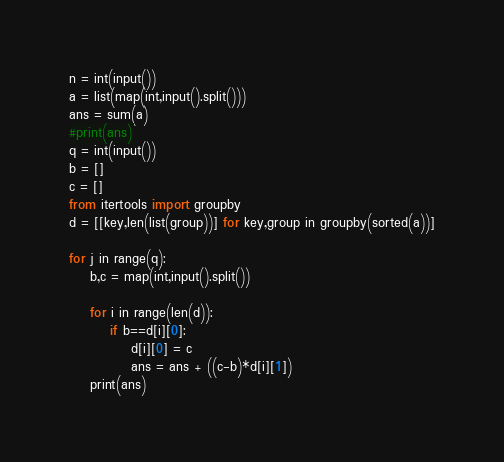<code> <loc_0><loc_0><loc_500><loc_500><_Python_>n = int(input())
a = list(map(int,input().split()))
ans = sum(a)
#print(ans)
q = int(input())
b = []
c = []
from itertools import groupby
d = [[key,len(list(group))] for key,group in groupby(sorted(a))]

for j in range(q):
    b,c = map(int,input().split())
    
    for i in range(len(d)):
        if b==d[i][0]:
            d[i][0] = c
            ans = ans + ((c-b)*d[i][1])
    print(ans)</code> 